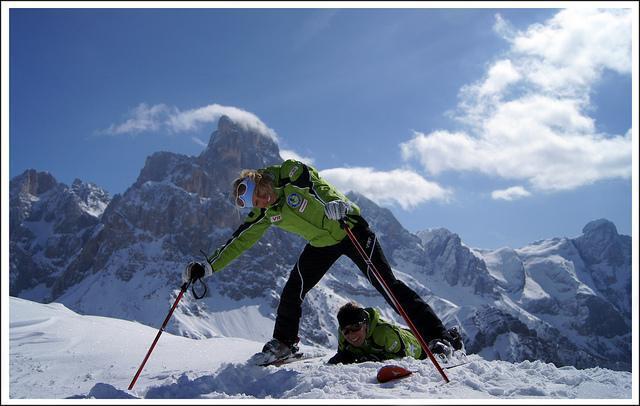How many people are in the picture?
Give a very brief answer. 2. 